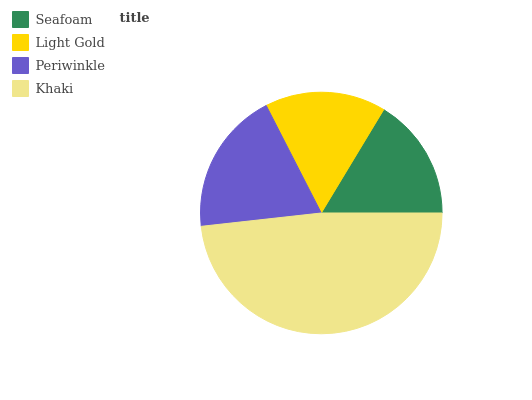Is Light Gold the minimum?
Answer yes or no. Yes. Is Khaki the maximum?
Answer yes or no. Yes. Is Periwinkle the minimum?
Answer yes or no. No. Is Periwinkle the maximum?
Answer yes or no. No. Is Periwinkle greater than Light Gold?
Answer yes or no. Yes. Is Light Gold less than Periwinkle?
Answer yes or no. Yes. Is Light Gold greater than Periwinkle?
Answer yes or no. No. Is Periwinkle less than Light Gold?
Answer yes or no. No. Is Periwinkle the high median?
Answer yes or no. Yes. Is Seafoam the low median?
Answer yes or no. Yes. Is Khaki the high median?
Answer yes or no. No. Is Periwinkle the low median?
Answer yes or no. No. 